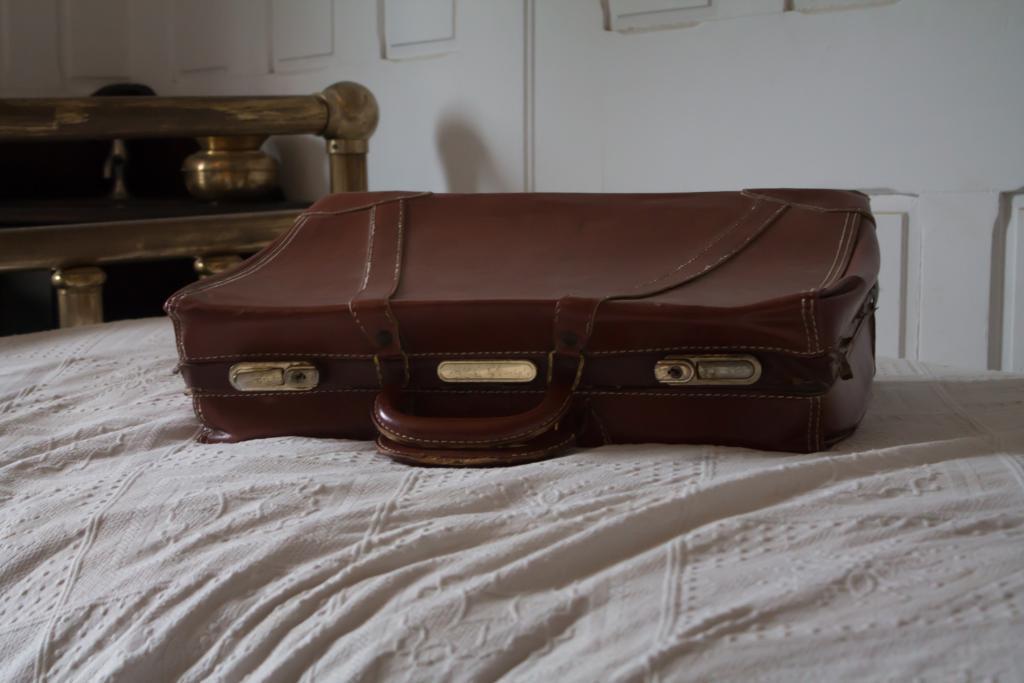Could you give a brief overview of what you see in this image? There is a brown suitcase on a white bed. 